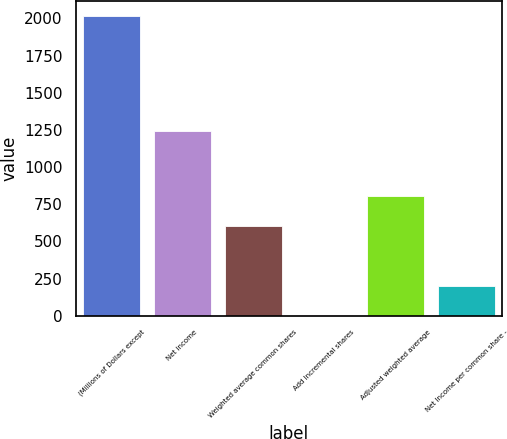Convert chart to OTSL. <chart><loc_0><loc_0><loc_500><loc_500><bar_chart><fcel>(Millions of Dollars except<fcel>Net income<fcel>Weighted average common shares<fcel>Add Incremental shares<fcel>Adjusted weighted average<fcel>Net Income per common share -<nl><fcel>2016<fcel>1245<fcel>605.85<fcel>1.5<fcel>807.3<fcel>202.95<nl></chart> 